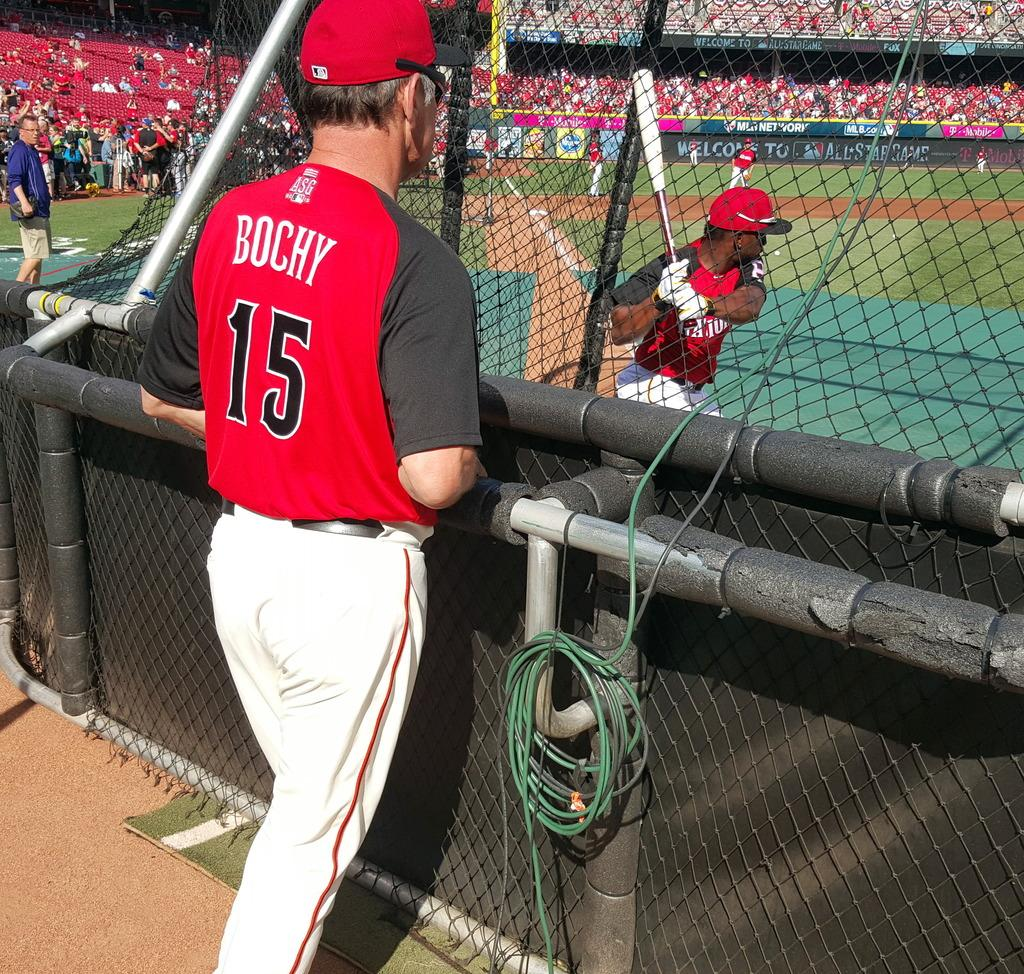Provide a one-sentence caption for the provided image. a player named BOCHY with the number 15 standing outside a baseball field. 